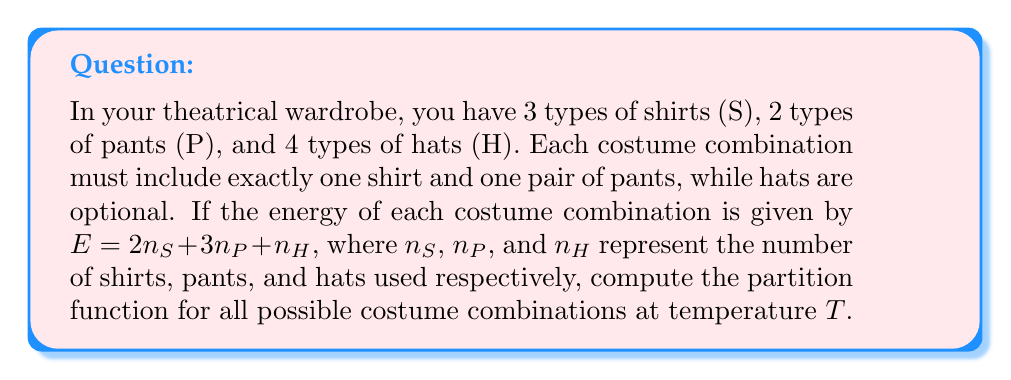Teach me how to tackle this problem. To solve this problem, we'll follow these steps:

1) First, recall that the partition function is given by:

   $$Z = \sum_i e^{-\beta E_i}$$

   where $\beta = \frac{1}{k_B T}$, $k_B$ is Boltzmann's constant, and $E_i$ are the possible energy states.

2) In this case, we have:
   - 3 shirt options (always one shirt: $n_S = 1$)
   - 2 pant options (always one pair: $n_P = 1$)
   - 5 hat options (0 to 4 hats: $n_H = 0, 1, 2, 3,$ or $4$)

3) The energy for each combination is:

   $$E = 2n_S + 3n_P + n_H = 2(1) + 3(1) + n_H = 5 + n_H$$

4) We can now write out the partition function:

   $$Z = \sum_{n_H=0}^4 3 \cdot 2 \cdot e^{-\beta(5+n_H)}$$

5) Simplify:

   $$Z = 6e^{-5\beta} \sum_{n_H=0}^4 e^{-\beta n_H}$$

6) This is a geometric series with 5 terms. The sum of a geometric series is given by:

   $$\frac{1-r^n}{1-r}$$

   where $r = e^{-\beta}$ and $n = 5$

7) Therefore:

   $$Z = 6e^{-5\beta} \cdot \frac{1-e^{-5\beta}}{1-e^{-\beta}}$$

8) This is our final expression for the partition function.
Answer: $$Z = 6e^{-5\beta} \cdot \frac{1-e^{-5\beta}}{1-e^{-\beta}}$$ 